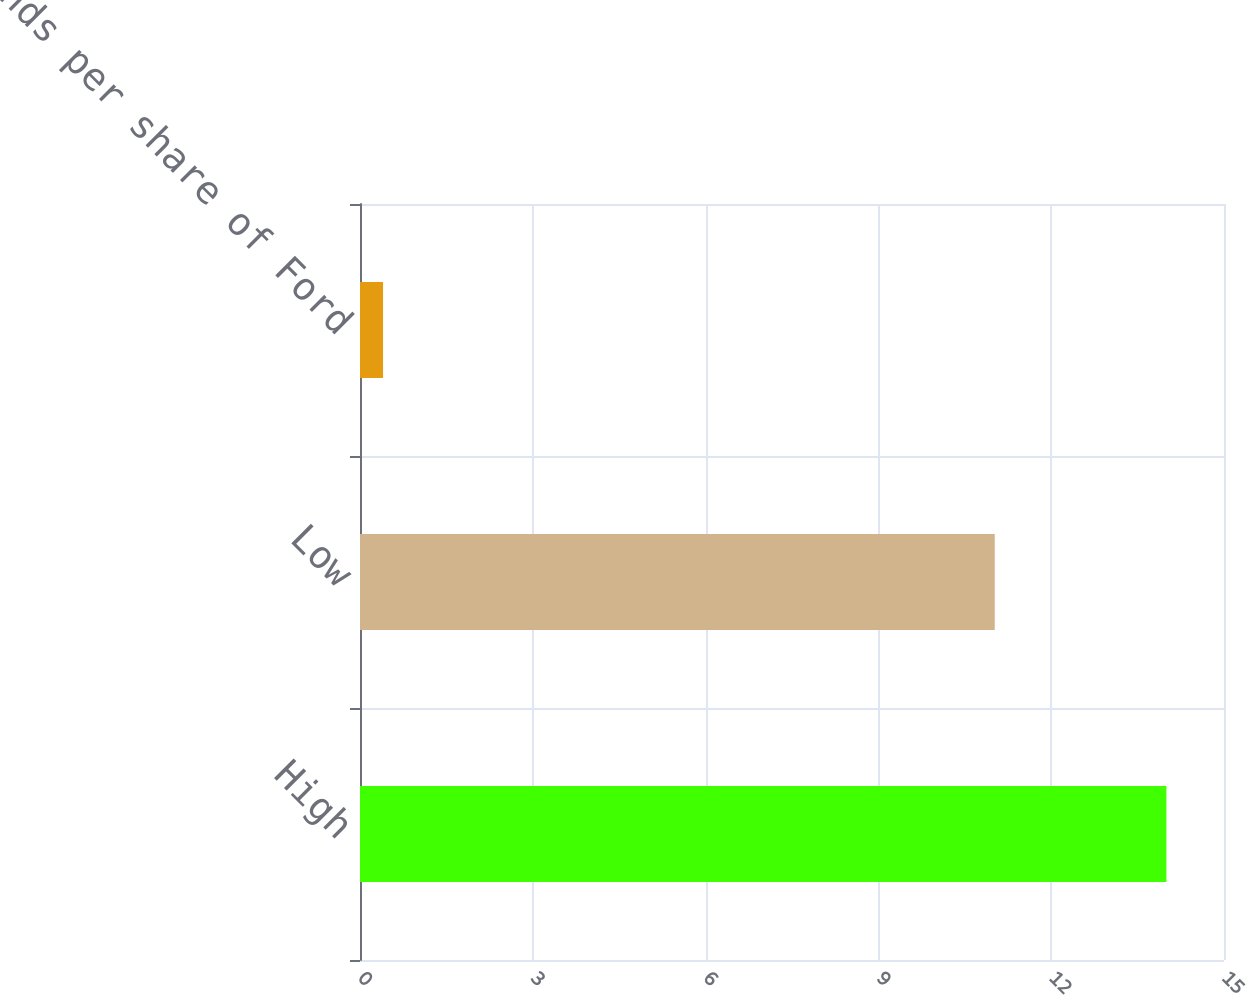Convert chart. <chart><loc_0><loc_0><loc_500><loc_500><bar_chart><fcel>High<fcel>Low<fcel>Dividends per share of Ford<nl><fcel>14<fcel>11.02<fcel>0.4<nl></chart> 